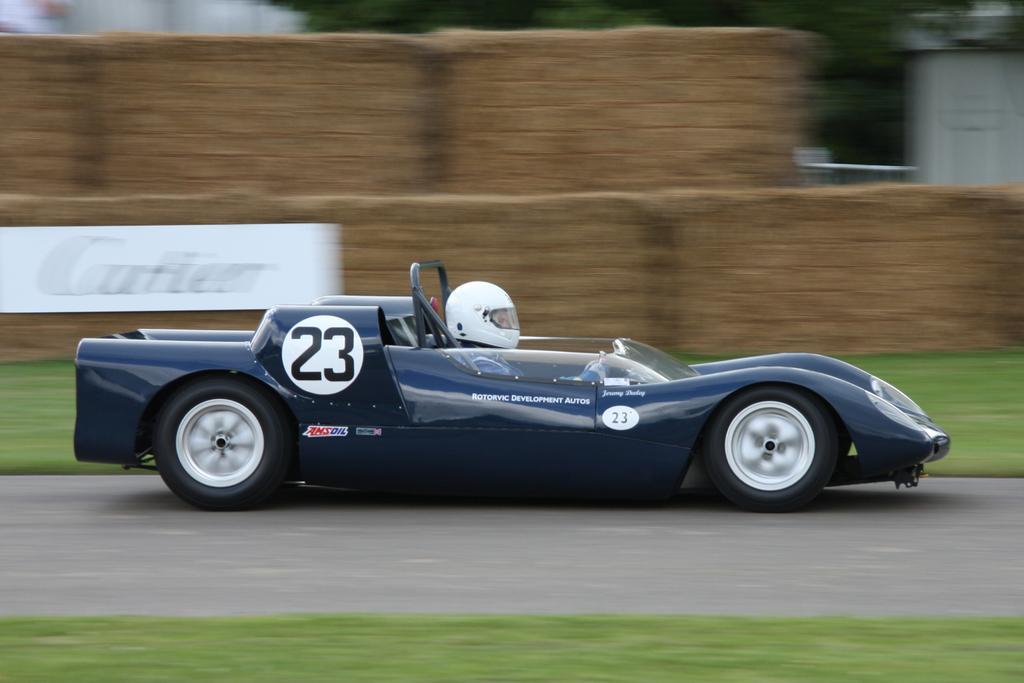Describe this image in one or two sentences. In the center of the image we can see one car on the road. And we can see one person sitting in the car and wearing a helmet. In the background there is a wall, banner, grass and a few other objects. 